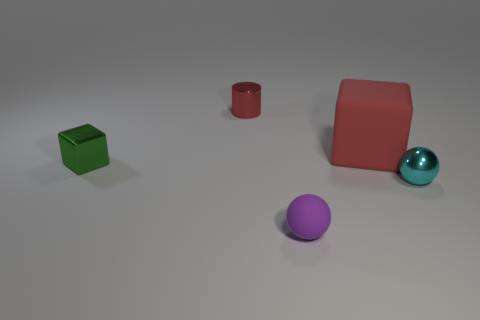Add 2 green metallic cubes. How many objects exist? 7 Subtract 1 spheres. How many spheres are left? 1 Subtract all red blocks. How many blocks are left? 1 Subtract 1 red cylinders. How many objects are left? 4 Subtract all blocks. How many objects are left? 3 Subtract all red cubes. Subtract all green cylinders. How many cubes are left? 1 Subtract all blue spheres. How many green blocks are left? 1 Subtract all tiny yellow rubber things. Subtract all tiny metal spheres. How many objects are left? 4 Add 3 tiny balls. How many tiny balls are left? 5 Add 5 big red matte spheres. How many big red matte spheres exist? 5 